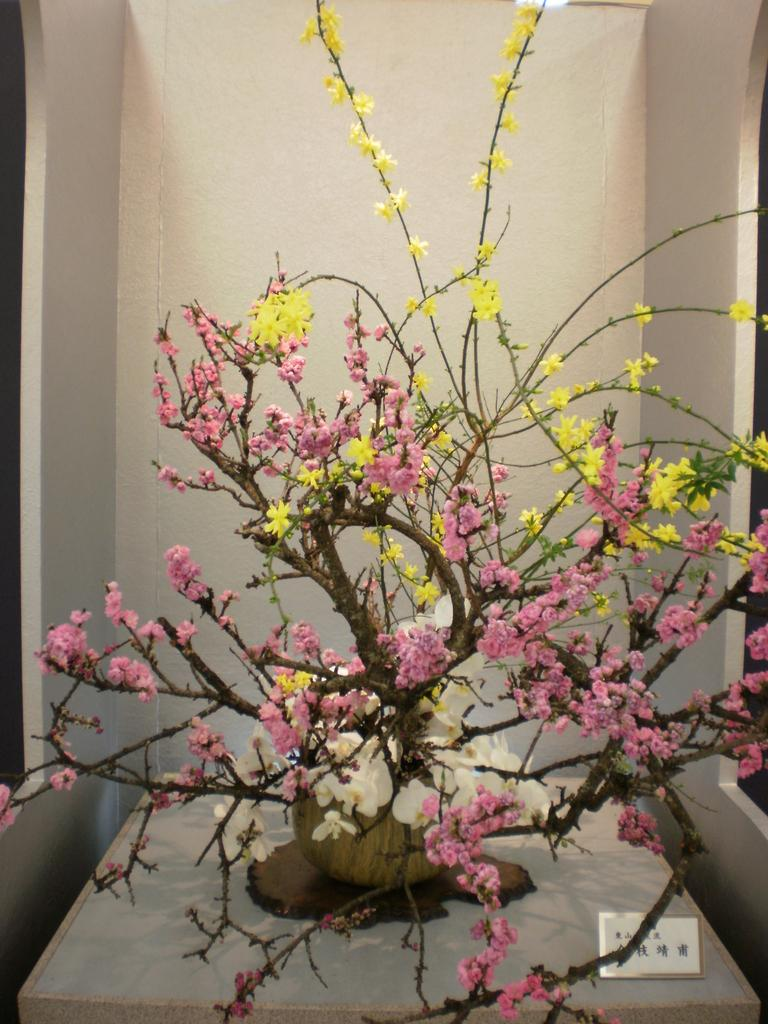What type of plant can be seen in the image? There is a plant in a pot with flowers in the image. Where is the plant placed? The plant is placed on a surface. What is located beside the plant? There is a name board beside the plant. What can be seen in the background of the image? There is a wall visible in the background of the image. Who is the creator of the wood structure seen in the image? There is no wood structure present in the image. 